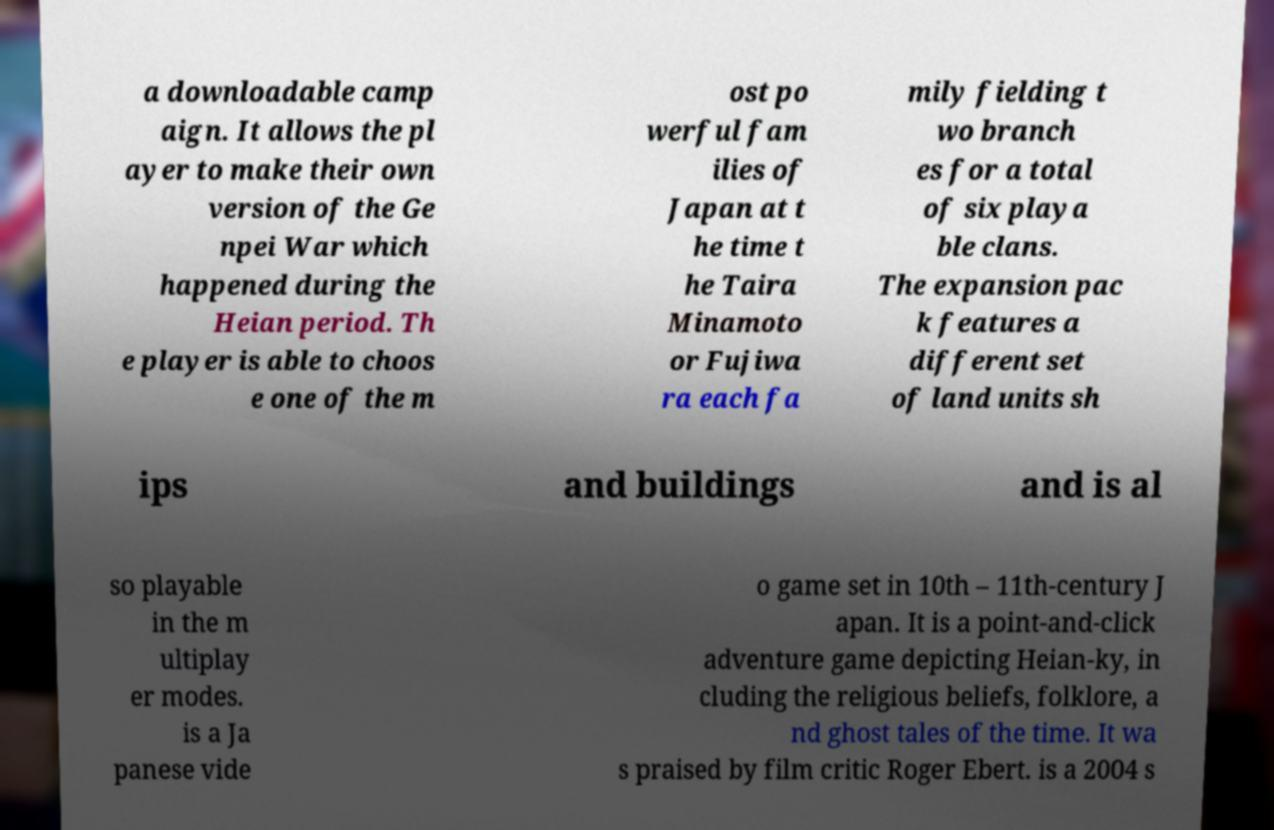There's text embedded in this image that I need extracted. Can you transcribe it verbatim? a downloadable camp aign. It allows the pl ayer to make their own version of the Ge npei War which happened during the Heian period. Th e player is able to choos e one of the m ost po werful fam ilies of Japan at t he time t he Taira Minamoto or Fujiwa ra each fa mily fielding t wo branch es for a total of six playa ble clans. The expansion pac k features a different set of land units sh ips and buildings and is al so playable in the m ultiplay er modes. is a Ja panese vide o game set in 10th – 11th-century J apan. It is a point-and-click adventure game depicting Heian-ky, in cluding the religious beliefs, folklore, a nd ghost tales of the time. It wa s praised by film critic Roger Ebert. is a 2004 s 